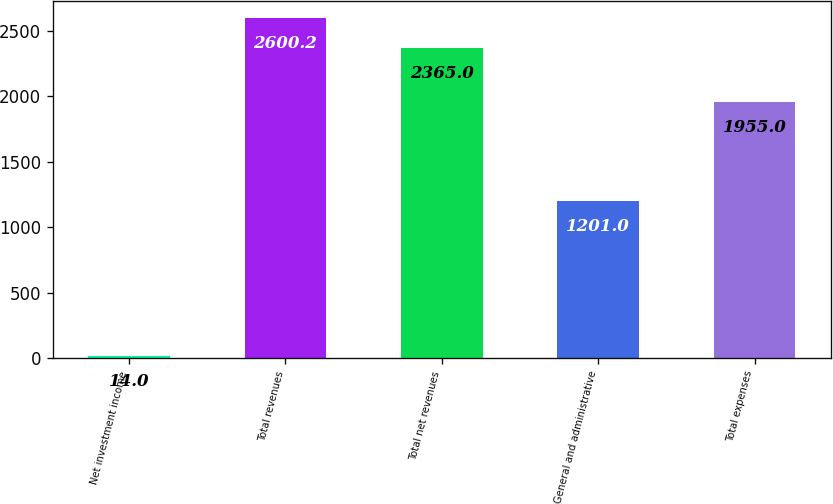Convert chart to OTSL. <chart><loc_0><loc_0><loc_500><loc_500><bar_chart><fcel>Net investment income<fcel>Total revenues<fcel>Total net revenues<fcel>General and administrative<fcel>Total expenses<nl><fcel>14<fcel>2600.2<fcel>2365<fcel>1201<fcel>1955<nl></chart> 